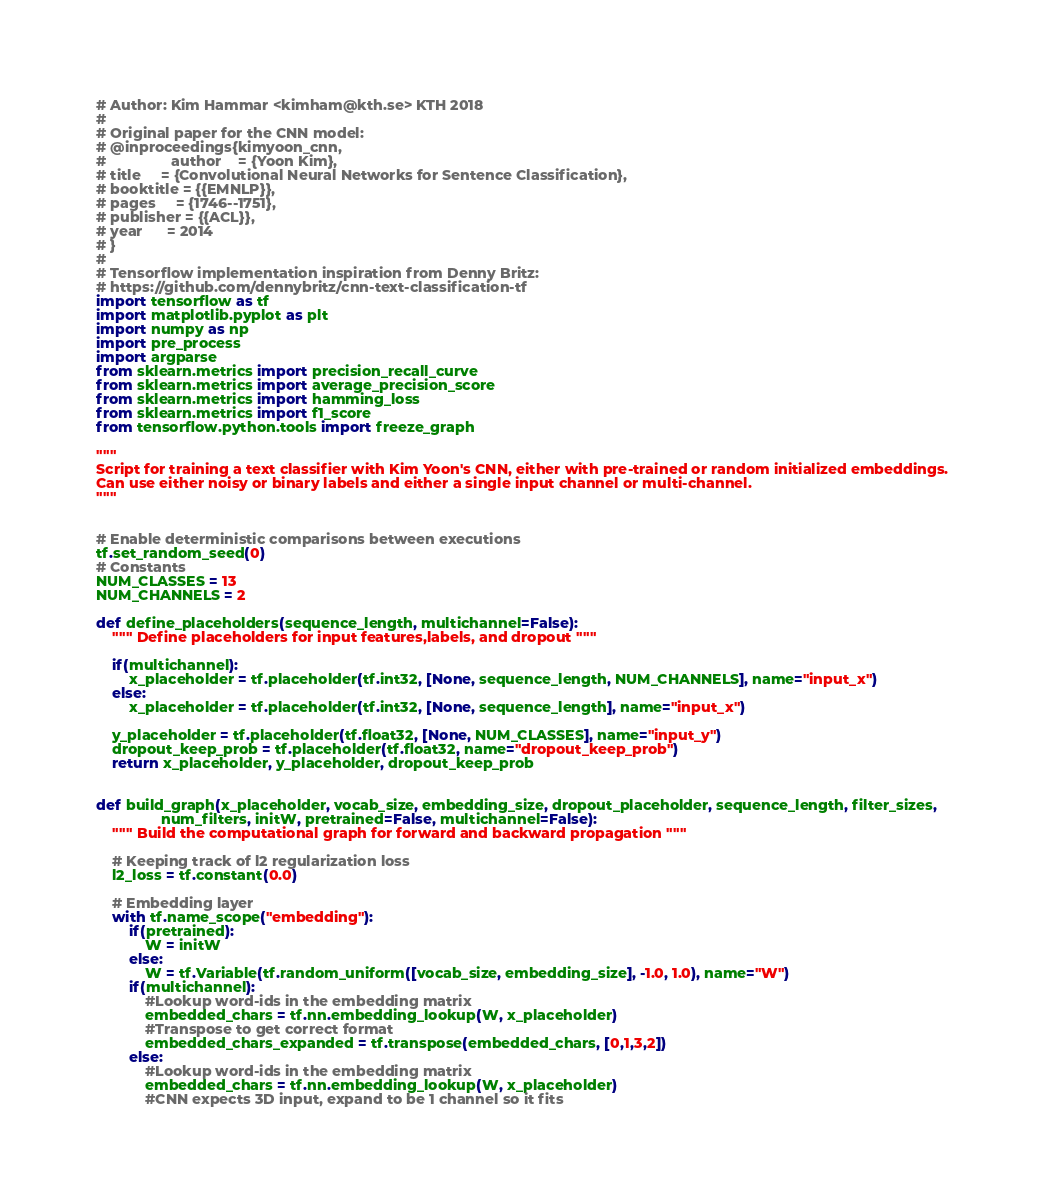Convert code to text. <code><loc_0><loc_0><loc_500><loc_500><_Python_># Author: Kim Hammar <kimham@kth.se> KTH 2018
#
# Original paper for the CNN model:
# @inproceedings{kimyoon_cnn,
#                author    = {Yoon Kim},
# title     = {Convolutional Neural Networks for Sentence Classification},
# booktitle = {{EMNLP}},
# pages     = {1746--1751},
# publisher = {{ACL}},
# year      = 2014
# }
#
# Tensorflow implementation inspiration from Denny Britz:
# https://github.com/dennybritz/cnn-text-classification-tf
import tensorflow as tf
import matplotlib.pyplot as plt
import numpy as np
import pre_process
import argparse
from sklearn.metrics import precision_recall_curve
from sklearn.metrics import average_precision_score
from sklearn.metrics import hamming_loss
from sklearn.metrics import f1_score
from tensorflow.python.tools import freeze_graph

"""
Script for training a text classifier with Kim Yoon's CNN, either with pre-trained or random initialized embeddings. 
Can use either noisy or binary labels and either a single input channel or multi-channel.
"""


# Enable deterministic comparisons between executions
tf.set_random_seed(0)
# Constants
NUM_CLASSES = 13
NUM_CHANNELS = 2

def define_placeholders(sequence_length, multichannel=False):
    """ Define placeholders for input features,labels, and dropout """

    if(multichannel):
        x_placeholder = tf.placeholder(tf.int32, [None, sequence_length, NUM_CHANNELS], name="input_x")
    else:
        x_placeholder = tf.placeholder(tf.int32, [None, sequence_length], name="input_x")

    y_placeholder = tf.placeholder(tf.float32, [None, NUM_CLASSES], name="input_y")
    dropout_keep_prob = tf.placeholder(tf.float32, name="dropout_keep_prob")
    return x_placeholder, y_placeholder, dropout_keep_prob


def build_graph(x_placeholder, vocab_size, embedding_size, dropout_placeholder, sequence_length, filter_sizes,
                num_filters, initW, pretrained=False, multichannel=False):
    """ Build the computational graph for forward and backward propagation """

    # Keeping track of l2 regularization loss
    l2_loss = tf.constant(0.0)

    # Embedding layer
    with tf.name_scope("embedding"):
        if(pretrained):
            W = initW
        else:
            W = tf.Variable(tf.random_uniform([vocab_size, embedding_size], -1.0, 1.0), name="W")
        if(multichannel):
            #Lookup word-ids in the embedding matrix
            embedded_chars = tf.nn.embedding_lookup(W, x_placeholder)
            #Transpose to get correct format
            embedded_chars_expanded = tf.transpose(embedded_chars, [0,1,3,2])
        else:
            #Lookup word-ids in the embedding matrix
            embedded_chars = tf.nn.embedding_lookup(W, x_placeholder)
            #CNN expects 3D input, expand to be 1 channel so it fits</code> 